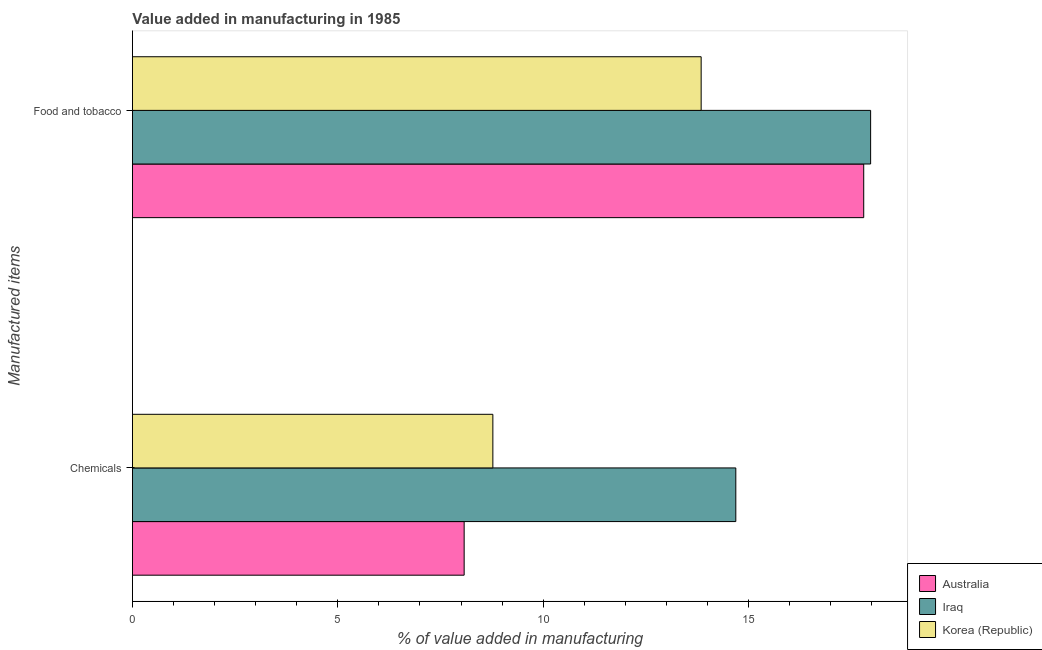How many different coloured bars are there?
Your answer should be compact. 3. How many bars are there on the 2nd tick from the top?
Ensure brevity in your answer.  3. How many bars are there on the 2nd tick from the bottom?
Keep it short and to the point. 3. What is the label of the 1st group of bars from the top?
Make the answer very short. Food and tobacco. What is the value added by  manufacturing chemicals in Korea (Republic)?
Offer a very short reply. 8.77. Across all countries, what is the maximum value added by  manufacturing chemicals?
Your response must be concise. 14.69. Across all countries, what is the minimum value added by  manufacturing chemicals?
Keep it short and to the point. 8.08. In which country was the value added by manufacturing food and tobacco maximum?
Provide a short and direct response. Iraq. In which country was the value added by manufacturing food and tobacco minimum?
Keep it short and to the point. Korea (Republic). What is the total value added by  manufacturing chemicals in the graph?
Give a very brief answer. 31.54. What is the difference between the value added by  manufacturing chemicals in Australia and that in Korea (Republic)?
Your answer should be very brief. -0.7. What is the difference between the value added by manufacturing food and tobacco in Korea (Republic) and the value added by  manufacturing chemicals in Australia?
Your response must be concise. 5.77. What is the average value added by  manufacturing chemicals per country?
Your response must be concise. 10.51. What is the difference between the value added by manufacturing food and tobacco and value added by  manufacturing chemicals in Iraq?
Ensure brevity in your answer.  3.28. In how many countries, is the value added by  manufacturing chemicals greater than 16 %?
Give a very brief answer. 0. What is the ratio of the value added by manufacturing food and tobacco in Australia to that in Iraq?
Offer a terse response. 0.99. In how many countries, is the value added by manufacturing food and tobacco greater than the average value added by manufacturing food and tobacco taken over all countries?
Make the answer very short. 2. What does the 3rd bar from the top in Chemicals represents?
Keep it short and to the point. Australia. Are all the bars in the graph horizontal?
Your answer should be very brief. Yes. Are the values on the major ticks of X-axis written in scientific E-notation?
Ensure brevity in your answer.  No. Does the graph contain grids?
Give a very brief answer. No. How many legend labels are there?
Provide a short and direct response. 3. What is the title of the graph?
Offer a very short reply. Value added in manufacturing in 1985. What is the label or title of the X-axis?
Make the answer very short. % of value added in manufacturing. What is the label or title of the Y-axis?
Your response must be concise. Manufactured items. What is the % of value added in manufacturing of Australia in Chemicals?
Provide a succinct answer. 8.08. What is the % of value added in manufacturing of Iraq in Chemicals?
Make the answer very short. 14.69. What is the % of value added in manufacturing in Korea (Republic) in Chemicals?
Offer a very short reply. 8.77. What is the % of value added in manufacturing of Australia in Food and tobacco?
Provide a short and direct response. 17.8. What is the % of value added in manufacturing in Iraq in Food and tobacco?
Provide a succinct answer. 17.97. What is the % of value added in manufacturing in Korea (Republic) in Food and tobacco?
Give a very brief answer. 13.85. Across all Manufactured items, what is the maximum % of value added in manufacturing of Australia?
Your answer should be compact. 17.8. Across all Manufactured items, what is the maximum % of value added in manufacturing in Iraq?
Provide a short and direct response. 17.97. Across all Manufactured items, what is the maximum % of value added in manufacturing in Korea (Republic)?
Your response must be concise. 13.85. Across all Manufactured items, what is the minimum % of value added in manufacturing in Australia?
Your response must be concise. 8.08. Across all Manufactured items, what is the minimum % of value added in manufacturing of Iraq?
Your answer should be very brief. 14.69. Across all Manufactured items, what is the minimum % of value added in manufacturing in Korea (Republic)?
Provide a succinct answer. 8.77. What is the total % of value added in manufacturing of Australia in the graph?
Provide a short and direct response. 25.88. What is the total % of value added in manufacturing of Iraq in the graph?
Provide a succinct answer. 32.66. What is the total % of value added in manufacturing of Korea (Republic) in the graph?
Give a very brief answer. 22.62. What is the difference between the % of value added in manufacturing in Australia in Chemicals and that in Food and tobacco?
Your answer should be compact. -9.73. What is the difference between the % of value added in manufacturing in Iraq in Chemicals and that in Food and tobacco?
Your response must be concise. -3.28. What is the difference between the % of value added in manufacturing in Korea (Republic) in Chemicals and that in Food and tobacco?
Your answer should be very brief. -5.07. What is the difference between the % of value added in manufacturing of Australia in Chemicals and the % of value added in manufacturing of Iraq in Food and tobacco?
Provide a succinct answer. -9.9. What is the difference between the % of value added in manufacturing of Australia in Chemicals and the % of value added in manufacturing of Korea (Republic) in Food and tobacco?
Provide a short and direct response. -5.77. What is the difference between the % of value added in manufacturing in Iraq in Chemicals and the % of value added in manufacturing in Korea (Republic) in Food and tobacco?
Give a very brief answer. 0.84. What is the average % of value added in manufacturing of Australia per Manufactured items?
Provide a succinct answer. 12.94. What is the average % of value added in manufacturing in Iraq per Manufactured items?
Ensure brevity in your answer.  16.33. What is the average % of value added in manufacturing in Korea (Republic) per Manufactured items?
Provide a short and direct response. 11.31. What is the difference between the % of value added in manufacturing in Australia and % of value added in manufacturing in Iraq in Chemicals?
Ensure brevity in your answer.  -6.61. What is the difference between the % of value added in manufacturing of Australia and % of value added in manufacturing of Korea (Republic) in Chemicals?
Provide a succinct answer. -0.7. What is the difference between the % of value added in manufacturing of Iraq and % of value added in manufacturing of Korea (Republic) in Chemicals?
Your answer should be compact. 5.91. What is the difference between the % of value added in manufacturing of Australia and % of value added in manufacturing of Iraq in Food and tobacco?
Provide a short and direct response. -0.17. What is the difference between the % of value added in manufacturing in Australia and % of value added in manufacturing in Korea (Republic) in Food and tobacco?
Provide a short and direct response. 3.96. What is the difference between the % of value added in manufacturing in Iraq and % of value added in manufacturing in Korea (Republic) in Food and tobacco?
Keep it short and to the point. 4.13. What is the ratio of the % of value added in manufacturing of Australia in Chemicals to that in Food and tobacco?
Provide a succinct answer. 0.45. What is the ratio of the % of value added in manufacturing in Iraq in Chemicals to that in Food and tobacco?
Give a very brief answer. 0.82. What is the ratio of the % of value added in manufacturing in Korea (Republic) in Chemicals to that in Food and tobacco?
Provide a succinct answer. 0.63. What is the difference between the highest and the second highest % of value added in manufacturing in Australia?
Offer a terse response. 9.73. What is the difference between the highest and the second highest % of value added in manufacturing in Iraq?
Provide a succinct answer. 3.28. What is the difference between the highest and the second highest % of value added in manufacturing of Korea (Republic)?
Provide a succinct answer. 5.07. What is the difference between the highest and the lowest % of value added in manufacturing of Australia?
Keep it short and to the point. 9.73. What is the difference between the highest and the lowest % of value added in manufacturing of Iraq?
Your answer should be compact. 3.28. What is the difference between the highest and the lowest % of value added in manufacturing in Korea (Republic)?
Provide a short and direct response. 5.07. 